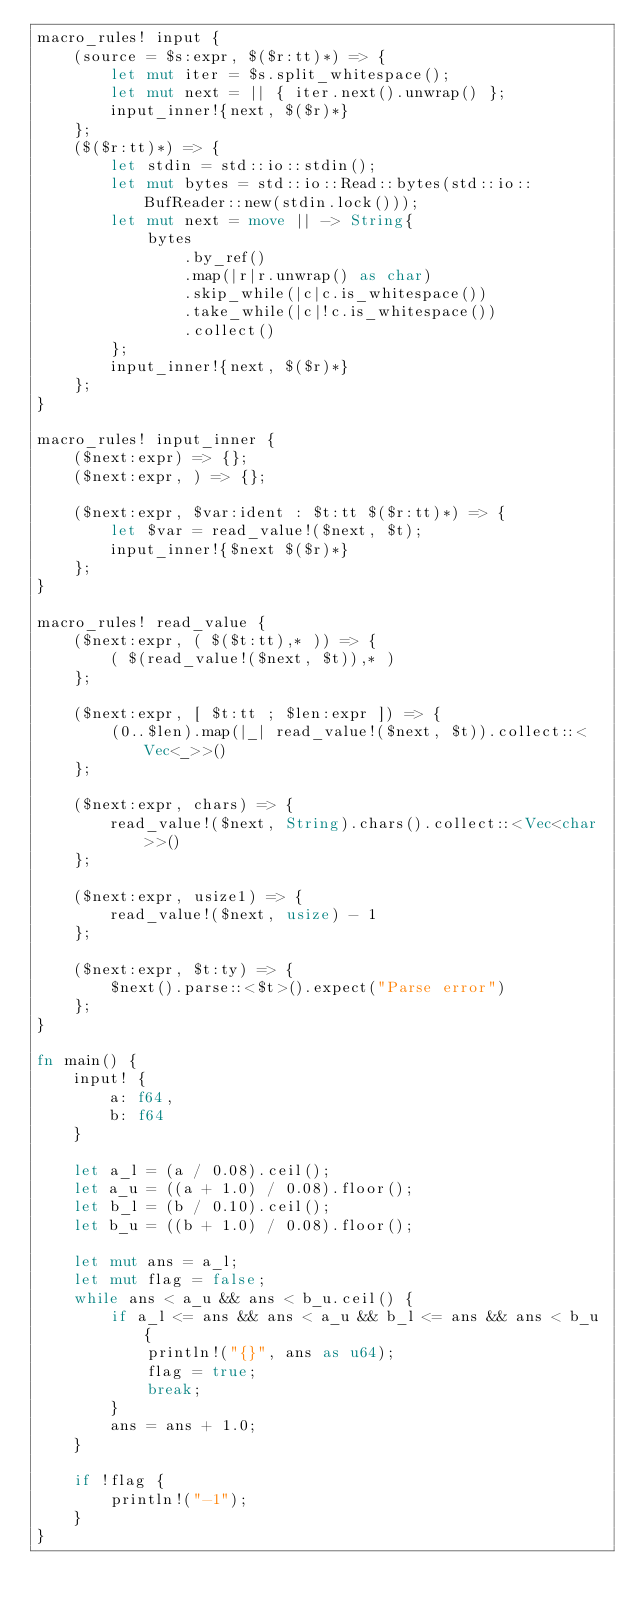Convert code to text. <code><loc_0><loc_0><loc_500><loc_500><_Rust_>macro_rules! input {
    (source = $s:expr, $($r:tt)*) => {
        let mut iter = $s.split_whitespace();
        let mut next = || { iter.next().unwrap() };
        input_inner!{next, $($r)*}
    };
    ($($r:tt)*) => {
        let stdin = std::io::stdin();
        let mut bytes = std::io::Read::bytes(std::io::BufReader::new(stdin.lock()));
        let mut next = move || -> String{
            bytes
                .by_ref()
                .map(|r|r.unwrap() as char)
                .skip_while(|c|c.is_whitespace())
                .take_while(|c|!c.is_whitespace())
                .collect()
        };
        input_inner!{next, $($r)*}
    };
}

macro_rules! input_inner {
    ($next:expr) => {};
    ($next:expr, ) => {};

    ($next:expr, $var:ident : $t:tt $($r:tt)*) => {
        let $var = read_value!($next, $t);
        input_inner!{$next $($r)*}
    };
}

macro_rules! read_value {
    ($next:expr, ( $($t:tt),* )) => {
        ( $(read_value!($next, $t)),* )
    };

    ($next:expr, [ $t:tt ; $len:expr ]) => {
        (0..$len).map(|_| read_value!($next, $t)).collect::<Vec<_>>()
    };

    ($next:expr, chars) => {
        read_value!($next, String).chars().collect::<Vec<char>>()
    };

    ($next:expr, usize1) => {
        read_value!($next, usize) - 1
    };

    ($next:expr, $t:ty) => {
        $next().parse::<$t>().expect("Parse error")
    };
}

fn main() {
    input! {
        a: f64,
        b: f64
    }

    let a_l = (a / 0.08).ceil();
    let a_u = ((a + 1.0) / 0.08).floor();
    let b_l = (b / 0.10).ceil();
    let b_u = ((b + 1.0) / 0.08).floor();

    let mut ans = a_l;
    let mut flag = false;
    while ans < a_u && ans < b_u.ceil() {
        if a_l <= ans && ans < a_u && b_l <= ans && ans < b_u {
            println!("{}", ans as u64);
            flag = true;
            break;
        }
        ans = ans + 1.0;
    }

    if !flag {
        println!("-1");
    }
}
</code> 